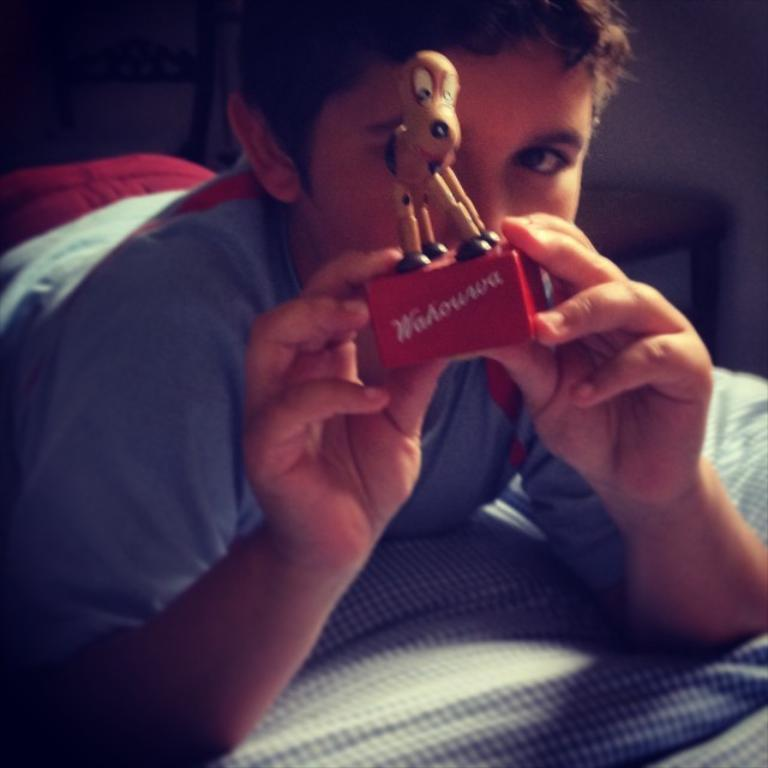Who is the main subject in the image? There is a boy in the image. What is the boy doing in the image? The boy is lying on the bed. What is the boy holding in the image? The boy is holding a toy. What can be seen in the background of the image? There is a wall and a table in the background of the image. What type of screw can be seen in the boy's mind in the image? There is no screw present in the image, nor is there any indication of the boy's thoughts or mental state. 